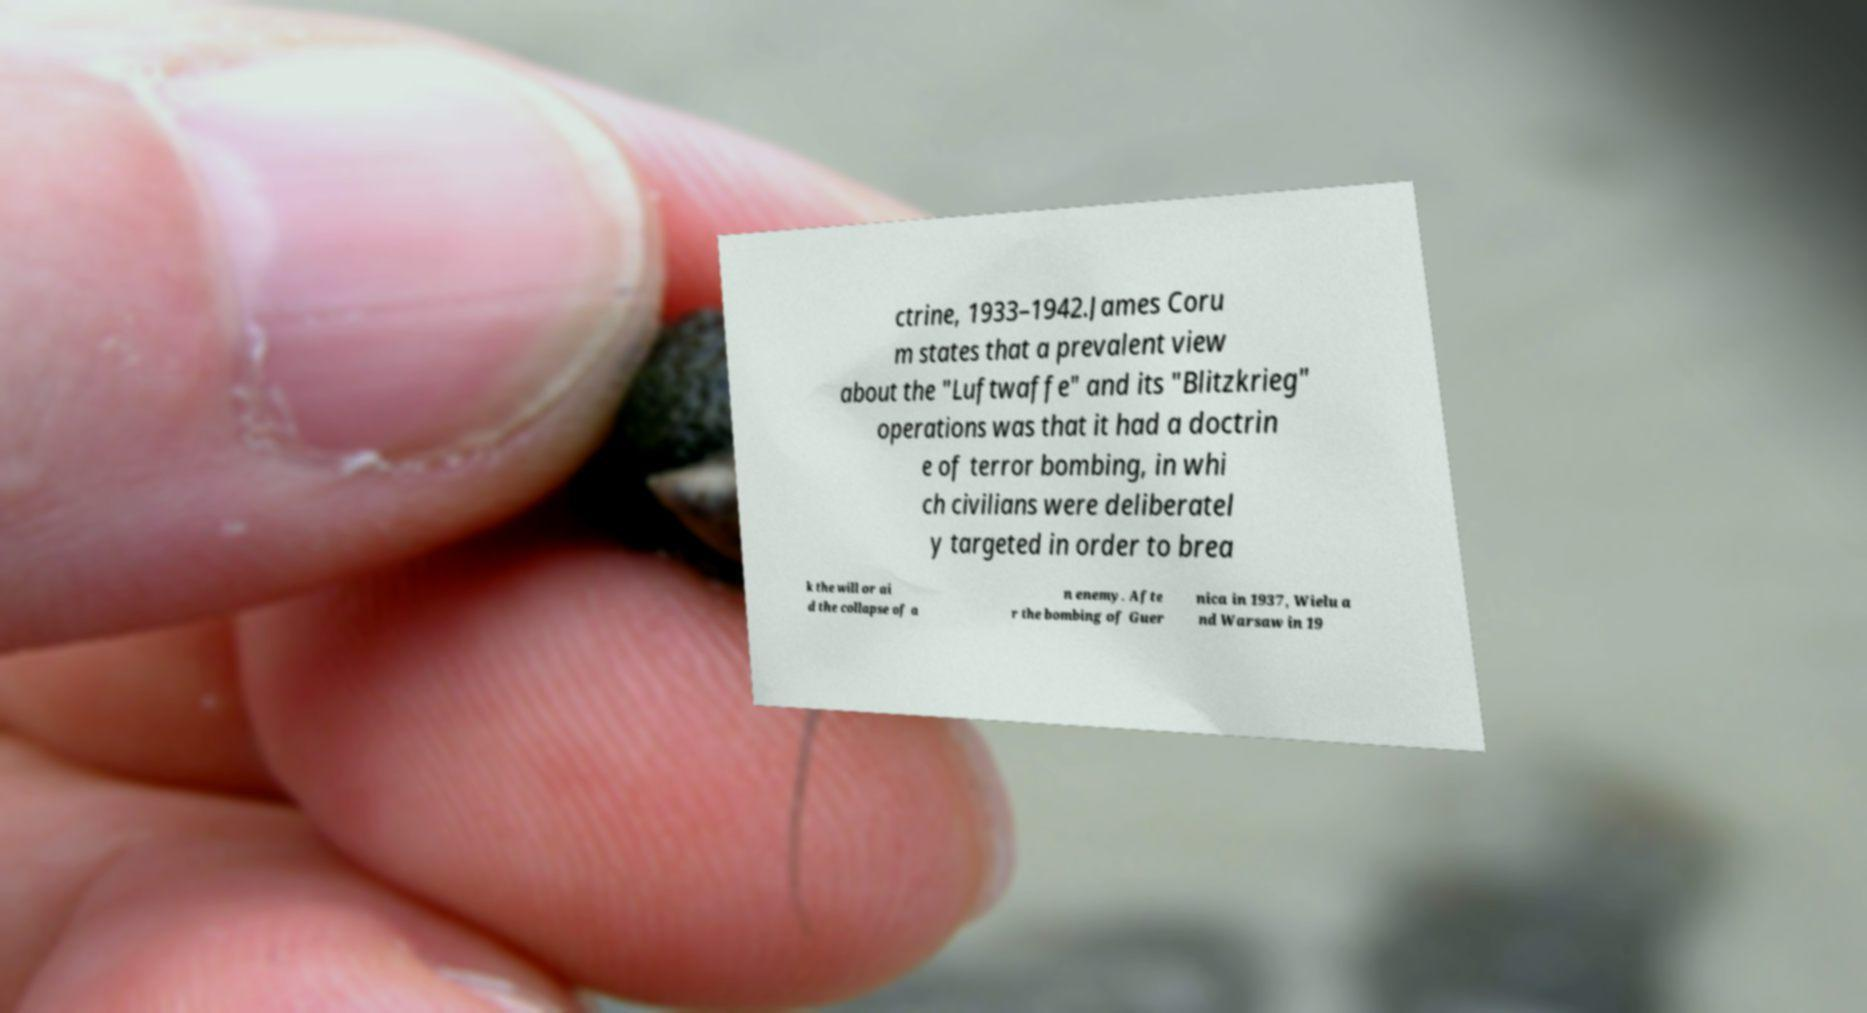There's text embedded in this image that I need extracted. Can you transcribe it verbatim? ctrine, 1933–1942.James Coru m states that a prevalent view about the "Luftwaffe" and its "Blitzkrieg" operations was that it had a doctrin e of terror bombing, in whi ch civilians were deliberatel y targeted in order to brea k the will or ai d the collapse of a n enemy. Afte r the bombing of Guer nica in 1937, Wielu a nd Warsaw in 19 